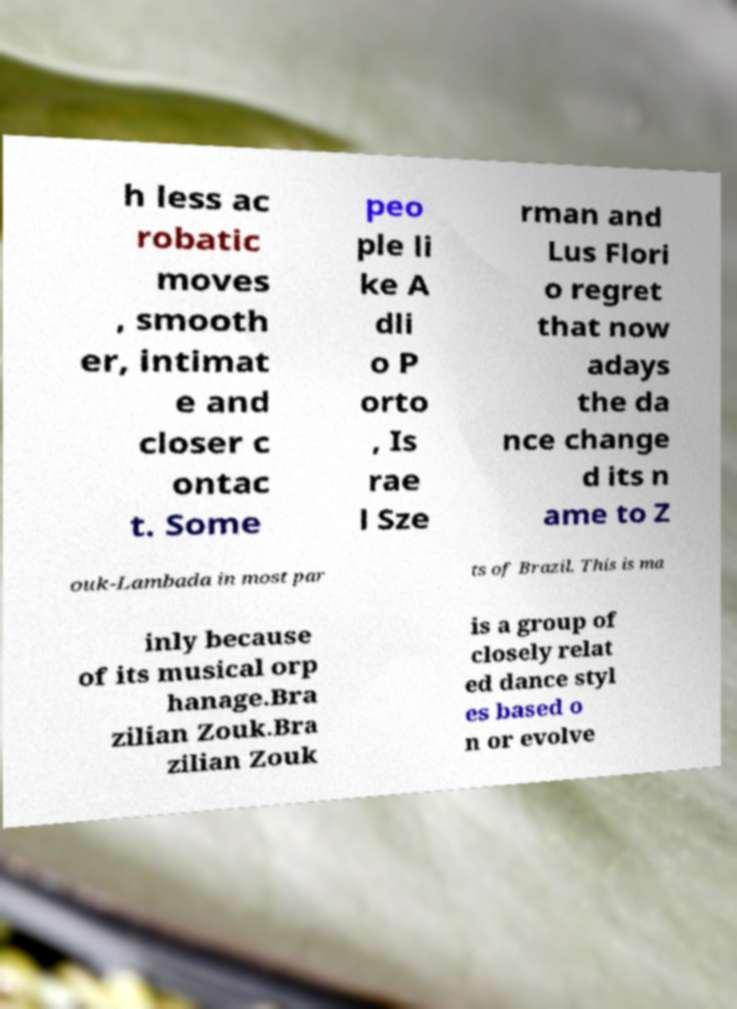Could you assist in decoding the text presented in this image and type it out clearly? h less ac robatic moves , smooth er, intimat e and closer c ontac t. Some peo ple li ke A dli o P orto , Is rae l Sze rman and Lus Flori o regret that now adays the da nce change d its n ame to Z ouk-Lambada in most par ts of Brazil. This is ma inly because of its musical orp hanage.Bra zilian Zouk.Bra zilian Zouk is a group of closely relat ed dance styl es based o n or evolve 